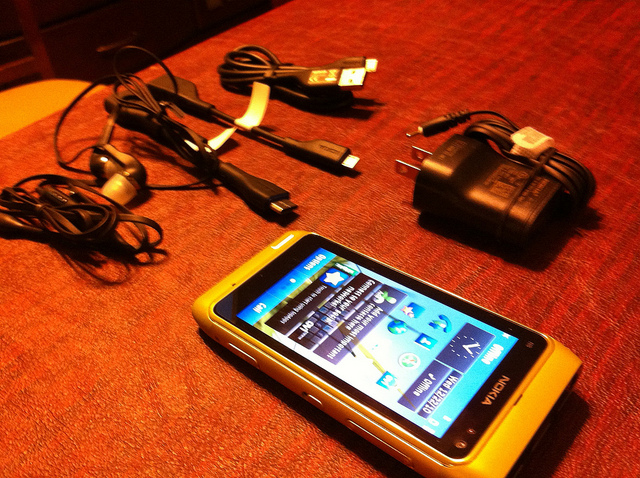Please extract the text content from this image. NOKIA HOW WO 10 poM 